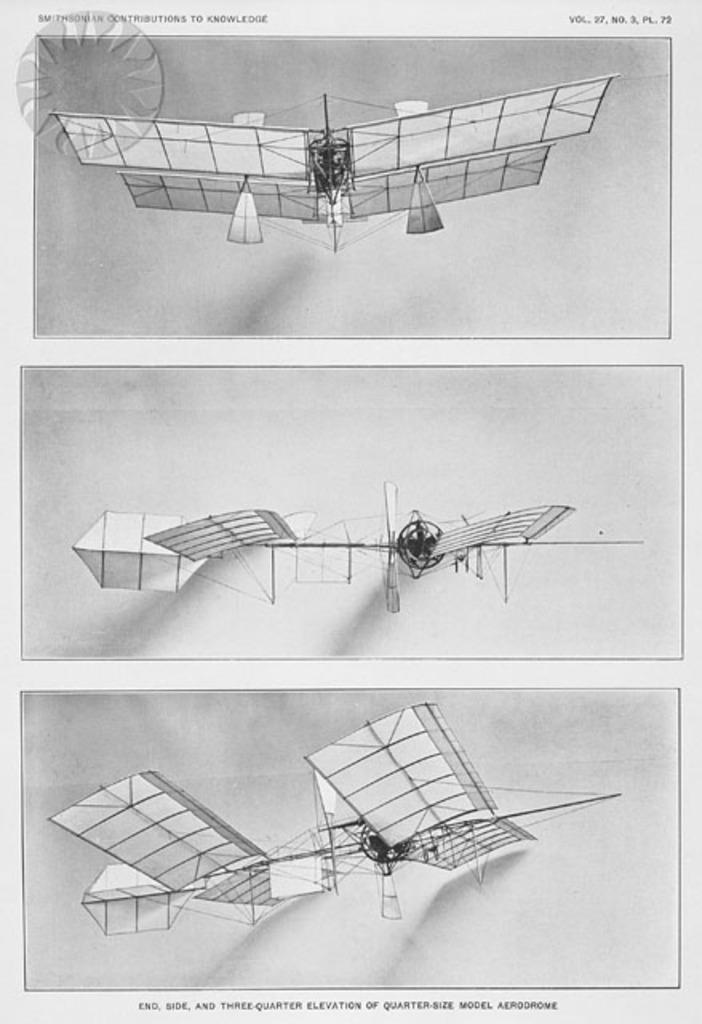<image>
Share a concise interpretation of the image provided. a diagram from the smithsonian contributions of knowledge is shown 